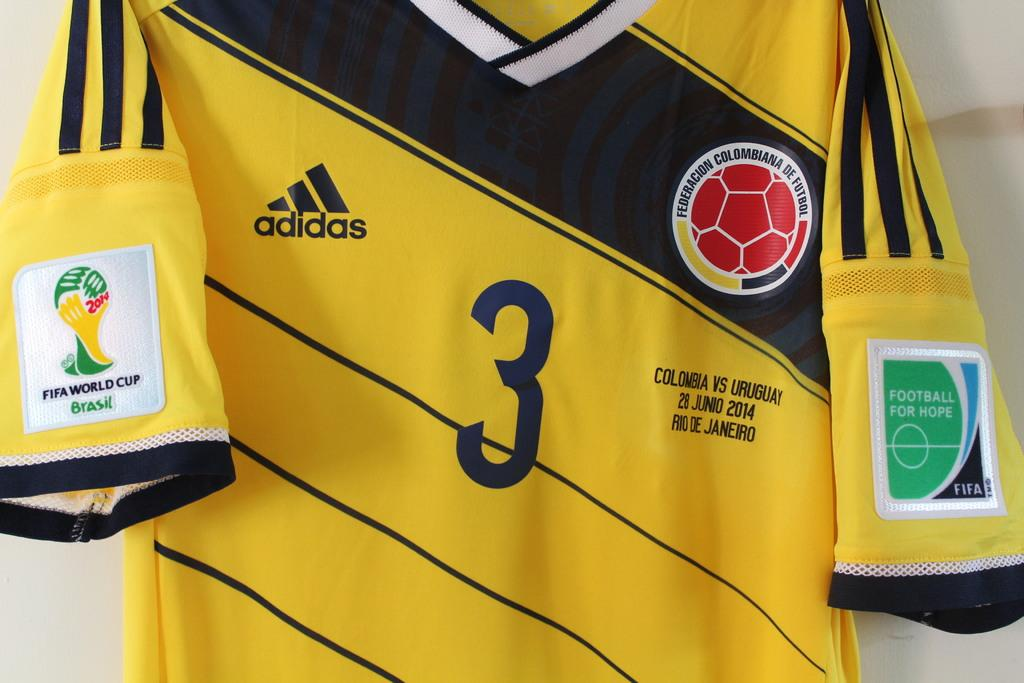<image>
Provide a brief description of the given image. An adidas jersey with the number three on it. 